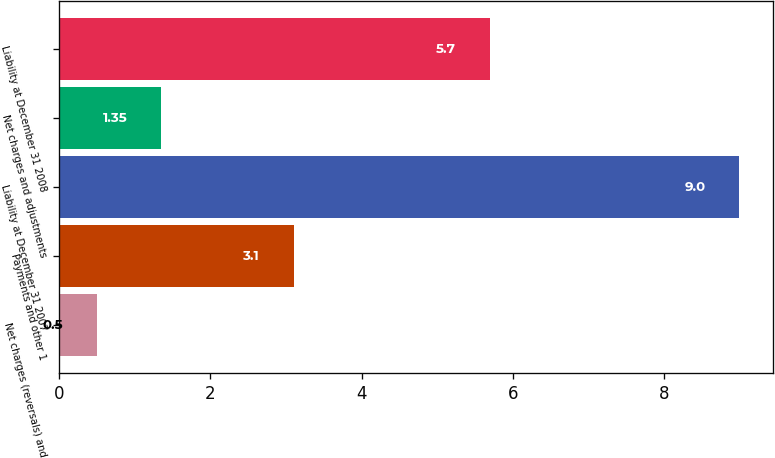Convert chart. <chart><loc_0><loc_0><loc_500><loc_500><bar_chart><fcel>Net charges (reversals) and<fcel>Payments and other 1<fcel>Liability at December 31 2007<fcel>Net charges and adjustments<fcel>Liability at December 31 2008<nl><fcel>0.5<fcel>3.1<fcel>9<fcel>1.35<fcel>5.7<nl></chart> 